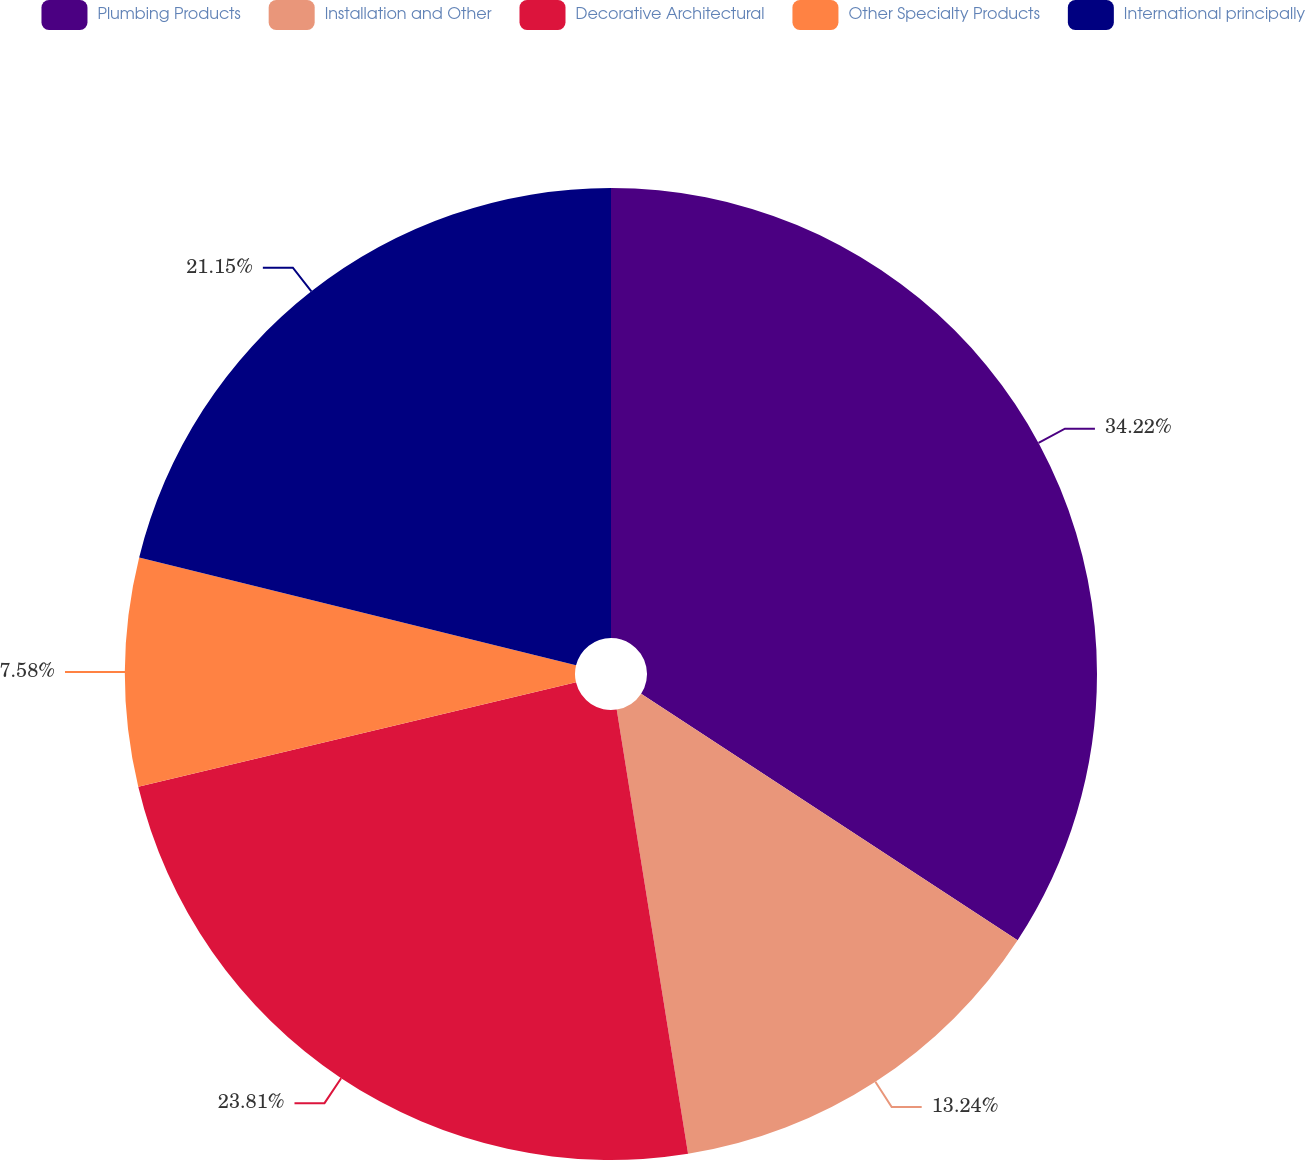Convert chart. <chart><loc_0><loc_0><loc_500><loc_500><pie_chart><fcel>Plumbing Products<fcel>Installation and Other<fcel>Decorative Architectural<fcel>Other Specialty Products<fcel>International principally<nl><fcel>34.23%<fcel>13.24%<fcel>23.81%<fcel>7.58%<fcel>21.15%<nl></chart> 